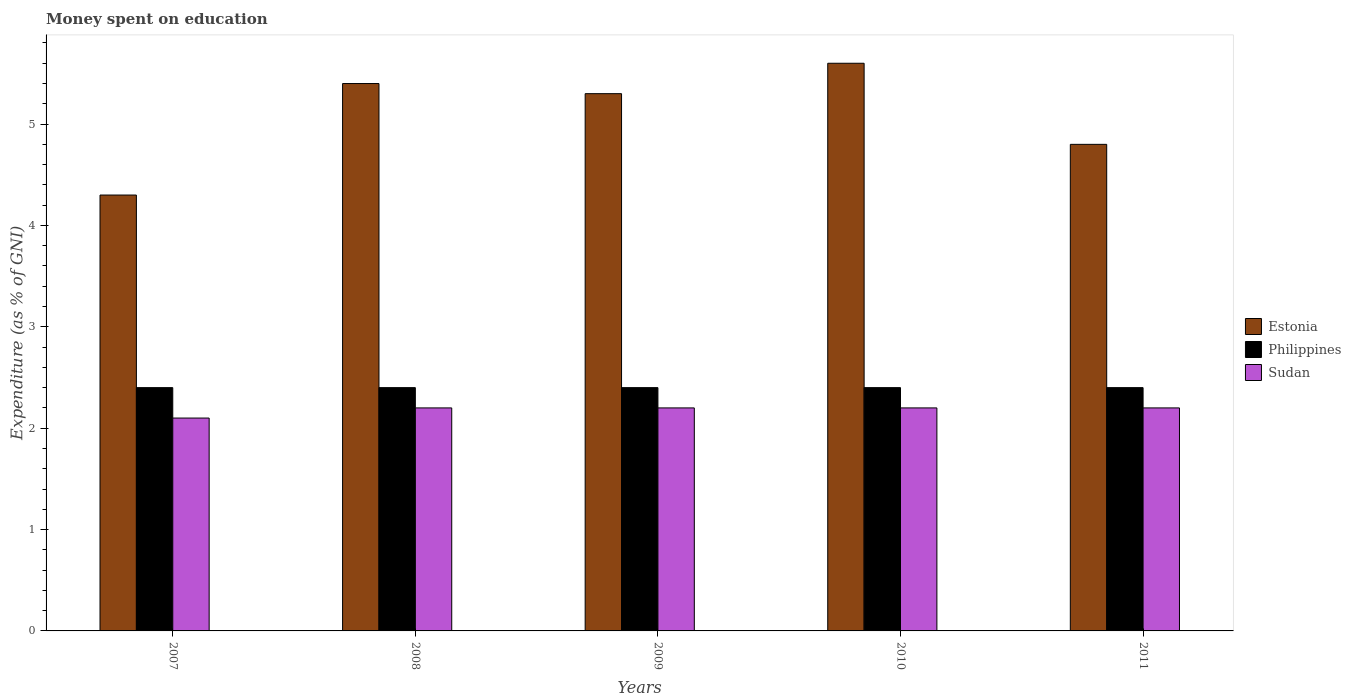How many different coloured bars are there?
Provide a short and direct response. 3. Are the number of bars per tick equal to the number of legend labels?
Offer a very short reply. Yes. Are the number of bars on each tick of the X-axis equal?
Ensure brevity in your answer.  Yes. In how many cases, is the number of bars for a given year not equal to the number of legend labels?
Your answer should be very brief. 0. What is the amount of money spent on education in Philippines in 2009?
Provide a short and direct response. 2.4. Across all years, what is the maximum amount of money spent on education in Philippines?
Offer a terse response. 2.4. Across all years, what is the minimum amount of money spent on education in Sudan?
Offer a terse response. 2.1. In which year was the amount of money spent on education in Sudan minimum?
Keep it short and to the point. 2007. What is the total amount of money spent on education in Sudan in the graph?
Make the answer very short. 10.9. What is the difference between the amount of money spent on education in Estonia in 2008 and that in 2011?
Make the answer very short. 0.6. What is the average amount of money spent on education in Estonia per year?
Offer a very short reply. 5.08. In the year 2008, what is the difference between the amount of money spent on education in Philippines and amount of money spent on education in Estonia?
Ensure brevity in your answer.  -3. What is the ratio of the amount of money spent on education in Estonia in 2008 to that in 2010?
Ensure brevity in your answer.  0.96. Is the amount of money spent on education in Estonia in 2008 less than that in 2010?
Keep it short and to the point. Yes. Is the difference between the amount of money spent on education in Philippines in 2007 and 2010 greater than the difference between the amount of money spent on education in Estonia in 2007 and 2010?
Provide a short and direct response. Yes. What is the difference between the highest and the second highest amount of money spent on education in Estonia?
Your answer should be compact. 0.2. What is the difference between the highest and the lowest amount of money spent on education in Estonia?
Provide a succinct answer. 1.3. In how many years, is the amount of money spent on education in Philippines greater than the average amount of money spent on education in Philippines taken over all years?
Provide a succinct answer. 0. What does the 3rd bar from the left in 2007 represents?
Your response must be concise. Sudan. How many bars are there?
Ensure brevity in your answer.  15. What is the difference between two consecutive major ticks on the Y-axis?
Ensure brevity in your answer.  1. Are the values on the major ticks of Y-axis written in scientific E-notation?
Ensure brevity in your answer.  No. How many legend labels are there?
Ensure brevity in your answer.  3. What is the title of the graph?
Provide a short and direct response. Money spent on education. What is the label or title of the Y-axis?
Offer a terse response. Expenditure (as % of GNI). What is the Expenditure (as % of GNI) in Estonia in 2007?
Ensure brevity in your answer.  4.3. What is the Expenditure (as % of GNI) in Philippines in 2007?
Your response must be concise. 2.4. What is the Expenditure (as % of GNI) of Sudan in 2007?
Offer a very short reply. 2.1. What is the Expenditure (as % of GNI) in Estonia in 2008?
Provide a succinct answer. 5.4. What is the Expenditure (as % of GNI) of Sudan in 2008?
Offer a terse response. 2.2. What is the Expenditure (as % of GNI) in Estonia in 2009?
Your answer should be compact. 5.3. What is the Expenditure (as % of GNI) in Sudan in 2009?
Keep it short and to the point. 2.2. What is the Expenditure (as % of GNI) in Estonia in 2010?
Make the answer very short. 5.6. What is the Expenditure (as % of GNI) in Philippines in 2010?
Give a very brief answer. 2.4. Across all years, what is the maximum Expenditure (as % of GNI) in Philippines?
Make the answer very short. 2.4. Across all years, what is the minimum Expenditure (as % of GNI) in Sudan?
Offer a terse response. 2.1. What is the total Expenditure (as % of GNI) of Estonia in the graph?
Make the answer very short. 25.4. What is the total Expenditure (as % of GNI) of Philippines in the graph?
Your response must be concise. 12. What is the total Expenditure (as % of GNI) in Sudan in the graph?
Keep it short and to the point. 10.9. What is the difference between the Expenditure (as % of GNI) in Estonia in 2007 and that in 2008?
Provide a succinct answer. -1.1. What is the difference between the Expenditure (as % of GNI) in Estonia in 2007 and that in 2011?
Ensure brevity in your answer.  -0.5. What is the difference between the Expenditure (as % of GNI) in Philippines in 2007 and that in 2011?
Your answer should be compact. 0. What is the difference between the Expenditure (as % of GNI) in Philippines in 2008 and that in 2009?
Offer a terse response. 0. What is the difference between the Expenditure (as % of GNI) of Sudan in 2008 and that in 2009?
Your answer should be very brief. 0. What is the difference between the Expenditure (as % of GNI) in Estonia in 2008 and that in 2010?
Offer a terse response. -0.2. What is the difference between the Expenditure (as % of GNI) of Philippines in 2008 and that in 2010?
Keep it short and to the point. 0. What is the difference between the Expenditure (as % of GNI) in Sudan in 2008 and that in 2010?
Give a very brief answer. 0. What is the difference between the Expenditure (as % of GNI) of Estonia in 2009 and that in 2010?
Provide a succinct answer. -0.3. What is the difference between the Expenditure (as % of GNI) of Philippines in 2009 and that in 2011?
Provide a succinct answer. 0. What is the difference between the Expenditure (as % of GNI) of Philippines in 2010 and that in 2011?
Ensure brevity in your answer.  0. What is the difference between the Expenditure (as % of GNI) in Estonia in 2007 and the Expenditure (as % of GNI) in Sudan in 2008?
Offer a terse response. 2.1. What is the difference between the Expenditure (as % of GNI) in Estonia in 2007 and the Expenditure (as % of GNI) in Sudan in 2009?
Offer a terse response. 2.1. What is the difference between the Expenditure (as % of GNI) in Philippines in 2007 and the Expenditure (as % of GNI) in Sudan in 2009?
Your answer should be very brief. 0.2. What is the difference between the Expenditure (as % of GNI) in Estonia in 2007 and the Expenditure (as % of GNI) in Sudan in 2010?
Offer a very short reply. 2.1. What is the difference between the Expenditure (as % of GNI) of Philippines in 2007 and the Expenditure (as % of GNI) of Sudan in 2010?
Keep it short and to the point. 0.2. What is the difference between the Expenditure (as % of GNI) in Estonia in 2008 and the Expenditure (as % of GNI) in Philippines in 2009?
Your answer should be compact. 3. What is the difference between the Expenditure (as % of GNI) of Estonia in 2008 and the Expenditure (as % of GNI) of Sudan in 2009?
Your answer should be compact. 3.2. What is the difference between the Expenditure (as % of GNI) of Estonia in 2008 and the Expenditure (as % of GNI) of Philippines in 2010?
Offer a terse response. 3. What is the difference between the Expenditure (as % of GNI) in Estonia in 2008 and the Expenditure (as % of GNI) in Sudan in 2010?
Your answer should be very brief. 3.2. What is the difference between the Expenditure (as % of GNI) of Philippines in 2008 and the Expenditure (as % of GNI) of Sudan in 2010?
Provide a short and direct response. 0.2. What is the difference between the Expenditure (as % of GNI) of Estonia in 2008 and the Expenditure (as % of GNI) of Philippines in 2011?
Your response must be concise. 3. What is the difference between the Expenditure (as % of GNI) of Estonia in 2008 and the Expenditure (as % of GNI) of Sudan in 2011?
Keep it short and to the point. 3.2. What is the difference between the Expenditure (as % of GNI) in Estonia in 2009 and the Expenditure (as % of GNI) in Sudan in 2010?
Offer a very short reply. 3.1. What is the difference between the Expenditure (as % of GNI) in Estonia in 2010 and the Expenditure (as % of GNI) in Sudan in 2011?
Give a very brief answer. 3.4. What is the average Expenditure (as % of GNI) in Estonia per year?
Make the answer very short. 5.08. What is the average Expenditure (as % of GNI) in Sudan per year?
Give a very brief answer. 2.18. In the year 2007, what is the difference between the Expenditure (as % of GNI) in Estonia and Expenditure (as % of GNI) in Philippines?
Provide a short and direct response. 1.9. In the year 2008, what is the difference between the Expenditure (as % of GNI) in Estonia and Expenditure (as % of GNI) in Philippines?
Your answer should be compact. 3. In the year 2008, what is the difference between the Expenditure (as % of GNI) of Estonia and Expenditure (as % of GNI) of Sudan?
Your answer should be compact. 3.2. In the year 2009, what is the difference between the Expenditure (as % of GNI) of Estonia and Expenditure (as % of GNI) of Philippines?
Keep it short and to the point. 2.9. In the year 2009, what is the difference between the Expenditure (as % of GNI) in Estonia and Expenditure (as % of GNI) in Sudan?
Provide a succinct answer. 3.1. In the year 2009, what is the difference between the Expenditure (as % of GNI) of Philippines and Expenditure (as % of GNI) of Sudan?
Provide a succinct answer. 0.2. In the year 2010, what is the difference between the Expenditure (as % of GNI) of Estonia and Expenditure (as % of GNI) of Sudan?
Provide a short and direct response. 3.4. In the year 2011, what is the difference between the Expenditure (as % of GNI) of Philippines and Expenditure (as % of GNI) of Sudan?
Keep it short and to the point. 0.2. What is the ratio of the Expenditure (as % of GNI) in Estonia in 2007 to that in 2008?
Offer a very short reply. 0.8. What is the ratio of the Expenditure (as % of GNI) in Sudan in 2007 to that in 2008?
Provide a short and direct response. 0.95. What is the ratio of the Expenditure (as % of GNI) of Estonia in 2007 to that in 2009?
Ensure brevity in your answer.  0.81. What is the ratio of the Expenditure (as % of GNI) of Philippines in 2007 to that in 2009?
Your answer should be compact. 1. What is the ratio of the Expenditure (as % of GNI) in Sudan in 2007 to that in 2009?
Give a very brief answer. 0.95. What is the ratio of the Expenditure (as % of GNI) in Estonia in 2007 to that in 2010?
Offer a very short reply. 0.77. What is the ratio of the Expenditure (as % of GNI) of Philippines in 2007 to that in 2010?
Give a very brief answer. 1. What is the ratio of the Expenditure (as % of GNI) in Sudan in 2007 to that in 2010?
Provide a short and direct response. 0.95. What is the ratio of the Expenditure (as % of GNI) of Estonia in 2007 to that in 2011?
Offer a very short reply. 0.9. What is the ratio of the Expenditure (as % of GNI) of Sudan in 2007 to that in 2011?
Your answer should be very brief. 0.95. What is the ratio of the Expenditure (as % of GNI) in Estonia in 2008 to that in 2009?
Make the answer very short. 1.02. What is the ratio of the Expenditure (as % of GNI) in Philippines in 2008 to that in 2009?
Ensure brevity in your answer.  1. What is the ratio of the Expenditure (as % of GNI) of Philippines in 2008 to that in 2010?
Your answer should be very brief. 1. What is the ratio of the Expenditure (as % of GNI) of Philippines in 2008 to that in 2011?
Your response must be concise. 1. What is the ratio of the Expenditure (as % of GNI) of Estonia in 2009 to that in 2010?
Provide a short and direct response. 0.95. What is the ratio of the Expenditure (as % of GNI) in Sudan in 2009 to that in 2010?
Your answer should be very brief. 1. What is the ratio of the Expenditure (as % of GNI) in Estonia in 2009 to that in 2011?
Your answer should be compact. 1.1. What is the ratio of the Expenditure (as % of GNI) in Estonia in 2010 to that in 2011?
Your response must be concise. 1.17. What is the ratio of the Expenditure (as % of GNI) of Sudan in 2010 to that in 2011?
Keep it short and to the point. 1. What is the difference between the highest and the second highest Expenditure (as % of GNI) in Estonia?
Your answer should be compact. 0.2. What is the difference between the highest and the second highest Expenditure (as % of GNI) in Philippines?
Make the answer very short. 0. What is the difference between the highest and the second highest Expenditure (as % of GNI) of Sudan?
Offer a terse response. 0. What is the difference between the highest and the lowest Expenditure (as % of GNI) in Sudan?
Ensure brevity in your answer.  0.1. 